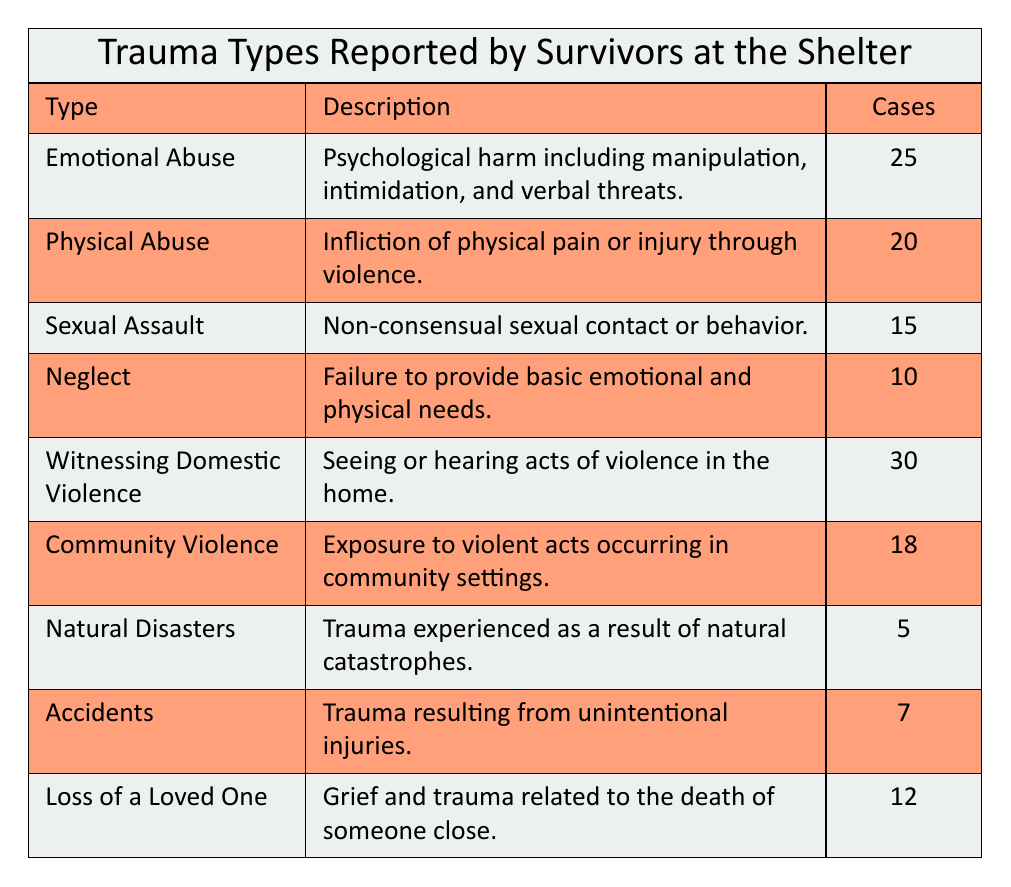What is the most reported type of trauma among survivors at the shelter? The table shows the reported cases for each type of trauma. The highest number of reported cases is 30 for "Witnessing Domestic Violence."
Answer: Witnessing Domestic Violence How many types of trauma are reported in total? The table lists 9 different types of trauma.
Answer: 9 Is the number of reported cases for Emotional Abuse greater than that for Neglect? The reported cases for Emotional Abuse are 25, while for Neglect, it is 10. Since 25 is greater than 10, the statement is true.
Answer: Yes What is the total number of reported cases for Physical Abuse and Sexual Assault combined? The number of reported cases for Physical Abuse is 20, and for Sexual Assault, it is 15. Adding these together gives 20 + 15 = 35.
Answer: 35 Does the table indicate that Natural Disasters have more reported cases than Accidents? The reported cases for Natural Disasters are 5, while for Accidents, it is 7. Since 5 is less than 7, the statement is false.
Answer: No What is the average number of reported cases for trauma types listed in the table? To find the average, first sum the reported cases: 25 + 20 + 15 + 10 + 30 + 18 + 5 + 7 + 12 = 142. There are 9 types of trauma, so the average is 142 / 9 = 15.78, which we can round to 16.
Answer: 16 How many more cases of Witnessing Domestic Violence are reported compared to Sexual Assault? The reported cases for Witnessing Domestic Violence are 30, and for Sexual Assault, it is 15. The difference is 30 - 15 = 15.
Answer: 15 Which type of trauma has the least reported cases and how many are there? Upon reviewing the table, "Natural Disasters" has the least reported cases with a total of 5.
Answer: Natural Disasters, 5 How many trauma types have reported cases greater than 15? The types of trauma with reported cases greater than 15 are "Emotional Abuse" (25), "Physical Abuse" (20), "Witnessing Domestic Violence" (30), and "Community Violence" (18). That gives a total of 4 types.
Answer: 4 